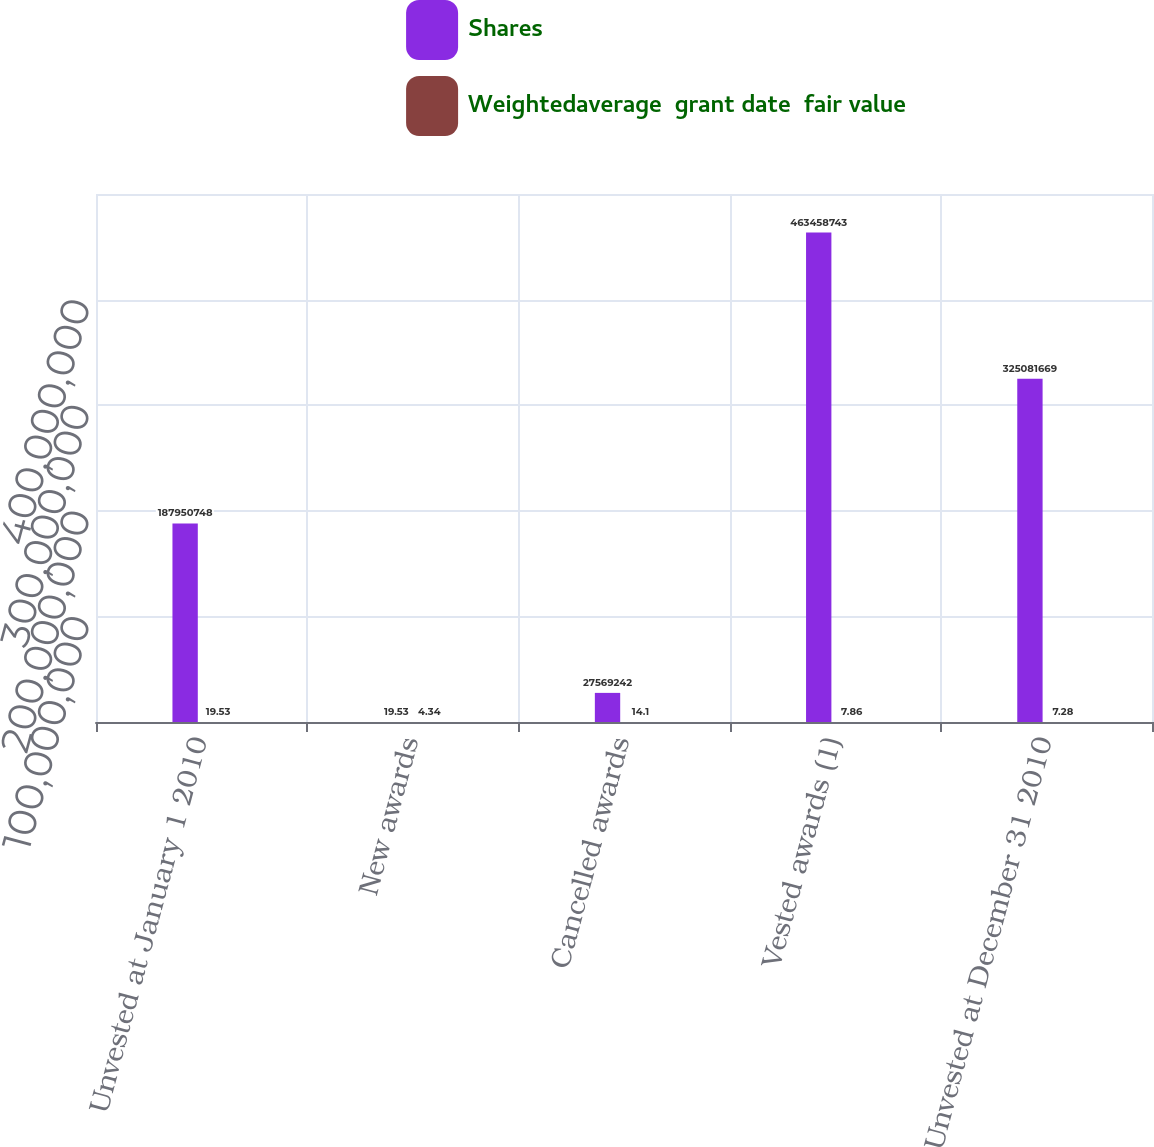Convert chart. <chart><loc_0><loc_0><loc_500><loc_500><stacked_bar_chart><ecel><fcel>Unvested at January 1 2010<fcel>New awards<fcel>Cancelled awards<fcel>Vested awards (1)<fcel>Unvested at December 31 2010<nl><fcel>Shares<fcel>1.87951e+08<fcel>19.53<fcel>2.75692e+07<fcel>4.63459e+08<fcel>3.25082e+08<nl><fcel>Weightedaverage  grant date  fair value<fcel>19.53<fcel>4.34<fcel>14.1<fcel>7.86<fcel>7.28<nl></chart> 